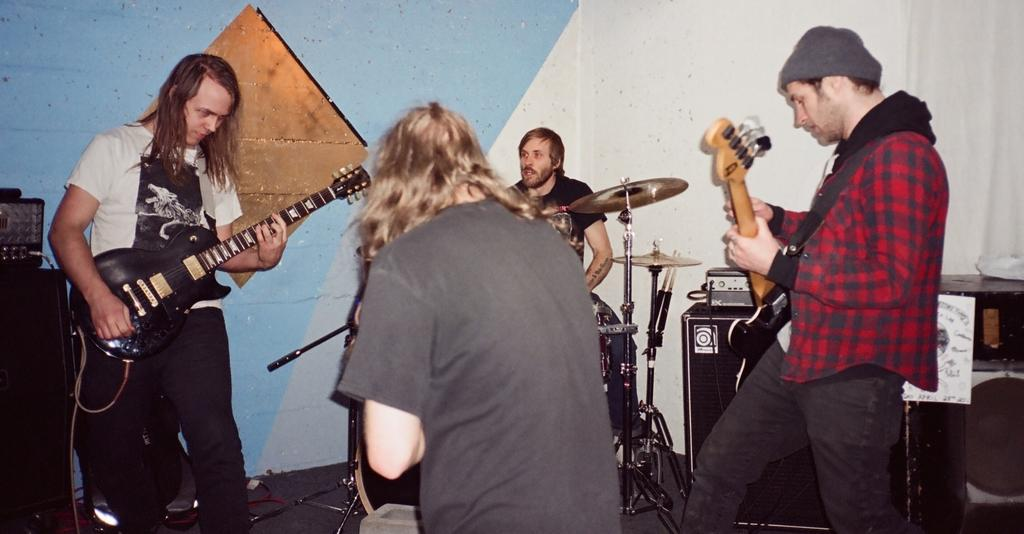How many people are in the image? There are four persons in the image. What are the persons doing in the image? The persons are playing musical instruments. What can be seen in the background of the image? There is a wall in the background of the image. Where is the throne located in the image? There is no throne present in the image. What type of magic is being performed by the persons in the image? There is no magic being performed in the image; the persons are playing musical instruments. 